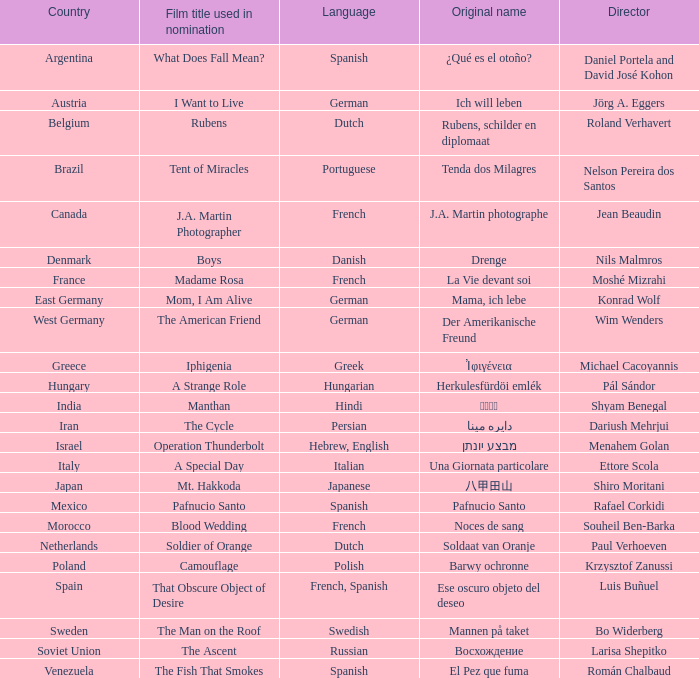Where is the director Dariush Mehrjui from? Iran. 